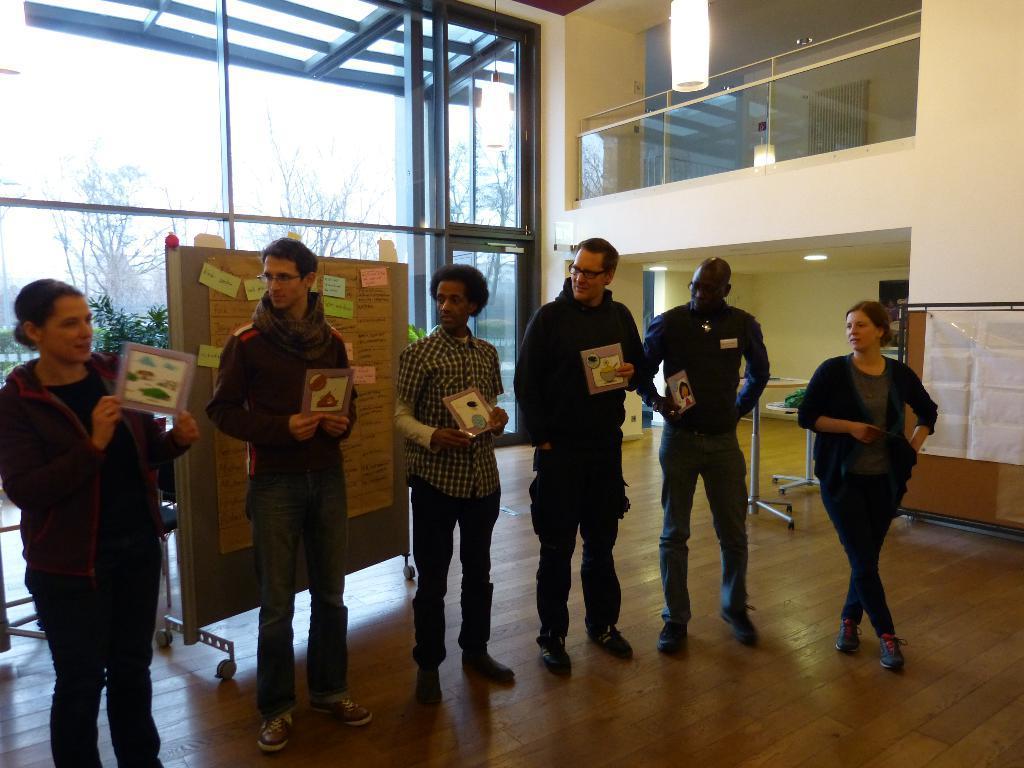In one or two sentences, can you explain what this image depicts? This picture is inside view of a room. We can see some persons are standing and holding a book. On the left side of the image sign board, trees, plants, door are present. On the right side of the image table, wall are present. At the top of the image light is there. At the bottom of the image floor is present. 